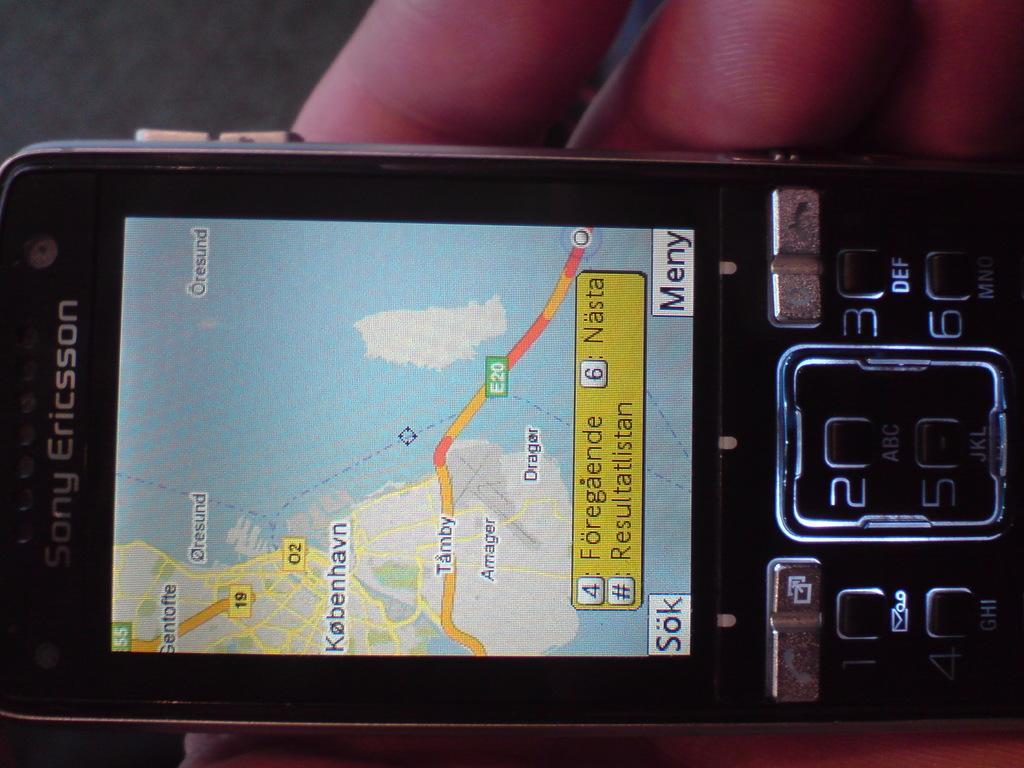<image>
Give a short and clear explanation of the subsequent image. A black Sony Ericsson phone shows a map on its display. 